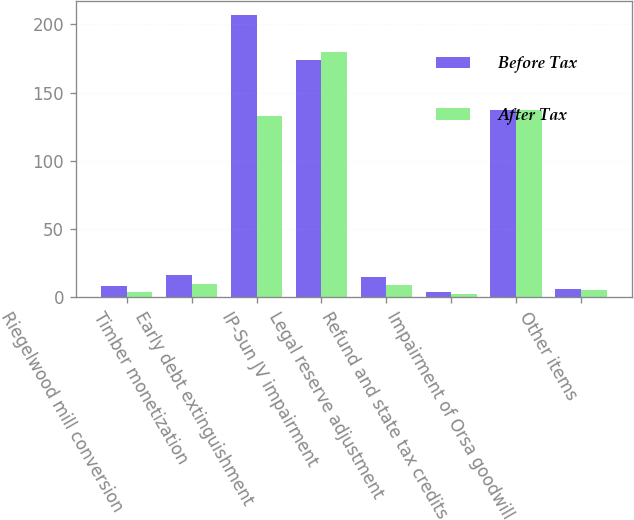Convert chart to OTSL. <chart><loc_0><loc_0><loc_500><loc_500><stacked_bar_chart><ecel><fcel>Riegelwood mill conversion<fcel>Timber monetization<fcel>Early debt extinguishment<fcel>IP-Sun JV impairment<fcel>Legal reserve adjustment<fcel>Refund and state tax credits<fcel>Impairment of Orsa goodwill<fcel>Other items<nl><fcel>Before Tax<fcel>8<fcel>16<fcel>207<fcel>174<fcel>15<fcel>4<fcel>137<fcel>6<nl><fcel>After Tax<fcel>4<fcel>10<fcel>133<fcel>180<fcel>9<fcel>2<fcel>137<fcel>5<nl></chart> 